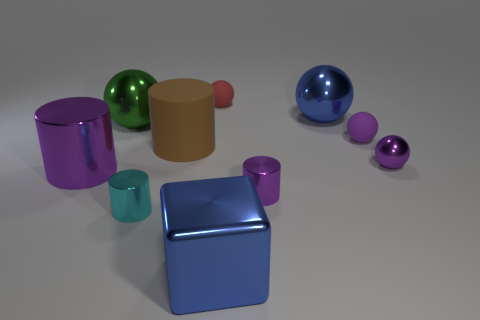Subtract 1 cylinders. How many cylinders are left? 3 Subtract all red spheres. How many spheres are left? 4 Subtract all small purple metallic spheres. How many spheres are left? 4 Subtract all gray cylinders. Subtract all gray balls. How many cylinders are left? 4 Subtract all cubes. How many objects are left? 9 Add 2 tiny red balls. How many tiny red balls exist? 3 Subtract 2 purple balls. How many objects are left? 8 Subtract all purple metallic things. Subtract all big blue cubes. How many objects are left? 6 Add 2 small purple objects. How many small purple objects are left? 5 